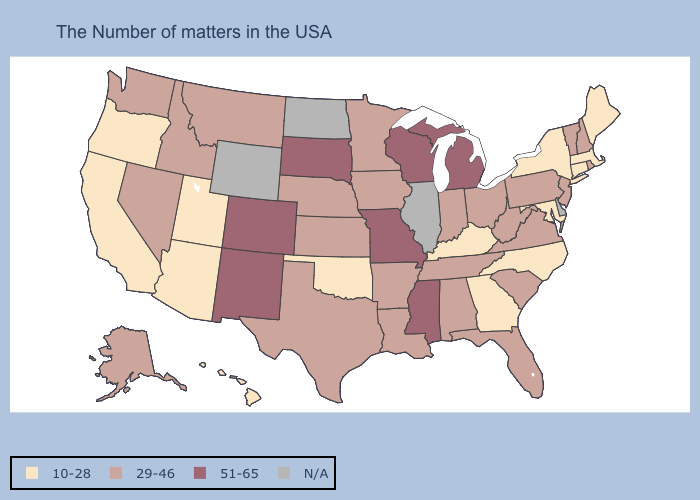Does the first symbol in the legend represent the smallest category?
Answer briefly. Yes. Name the states that have a value in the range 29-46?
Be succinct. Rhode Island, New Hampshire, Vermont, New Jersey, Pennsylvania, Virginia, South Carolina, West Virginia, Ohio, Florida, Indiana, Alabama, Tennessee, Louisiana, Arkansas, Minnesota, Iowa, Kansas, Nebraska, Texas, Montana, Idaho, Nevada, Washington, Alaska. Name the states that have a value in the range 51-65?
Be succinct. Michigan, Wisconsin, Mississippi, Missouri, South Dakota, Colorado, New Mexico. Name the states that have a value in the range 29-46?
Quick response, please. Rhode Island, New Hampshire, Vermont, New Jersey, Pennsylvania, Virginia, South Carolina, West Virginia, Ohio, Florida, Indiana, Alabama, Tennessee, Louisiana, Arkansas, Minnesota, Iowa, Kansas, Nebraska, Texas, Montana, Idaho, Nevada, Washington, Alaska. What is the value of Tennessee?
Give a very brief answer. 29-46. Which states have the lowest value in the MidWest?
Give a very brief answer. Ohio, Indiana, Minnesota, Iowa, Kansas, Nebraska. What is the value of Arkansas?
Keep it brief. 29-46. What is the value of North Carolina?
Be succinct. 10-28. Does Oregon have the highest value in the West?
Keep it brief. No. Name the states that have a value in the range 29-46?
Keep it brief. Rhode Island, New Hampshire, Vermont, New Jersey, Pennsylvania, Virginia, South Carolina, West Virginia, Ohio, Florida, Indiana, Alabama, Tennessee, Louisiana, Arkansas, Minnesota, Iowa, Kansas, Nebraska, Texas, Montana, Idaho, Nevada, Washington, Alaska. Name the states that have a value in the range 10-28?
Answer briefly. Maine, Massachusetts, Connecticut, New York, Maryland, North Carolina, Georgia, Kentucky, Oklahoma, Utah, Arizona, California, Oregon, Hawaii. Does Louisiana have the highest value in the USA?
Keep it brief. No. How many symbols are there in the legend?
Answer briefly. 4. 